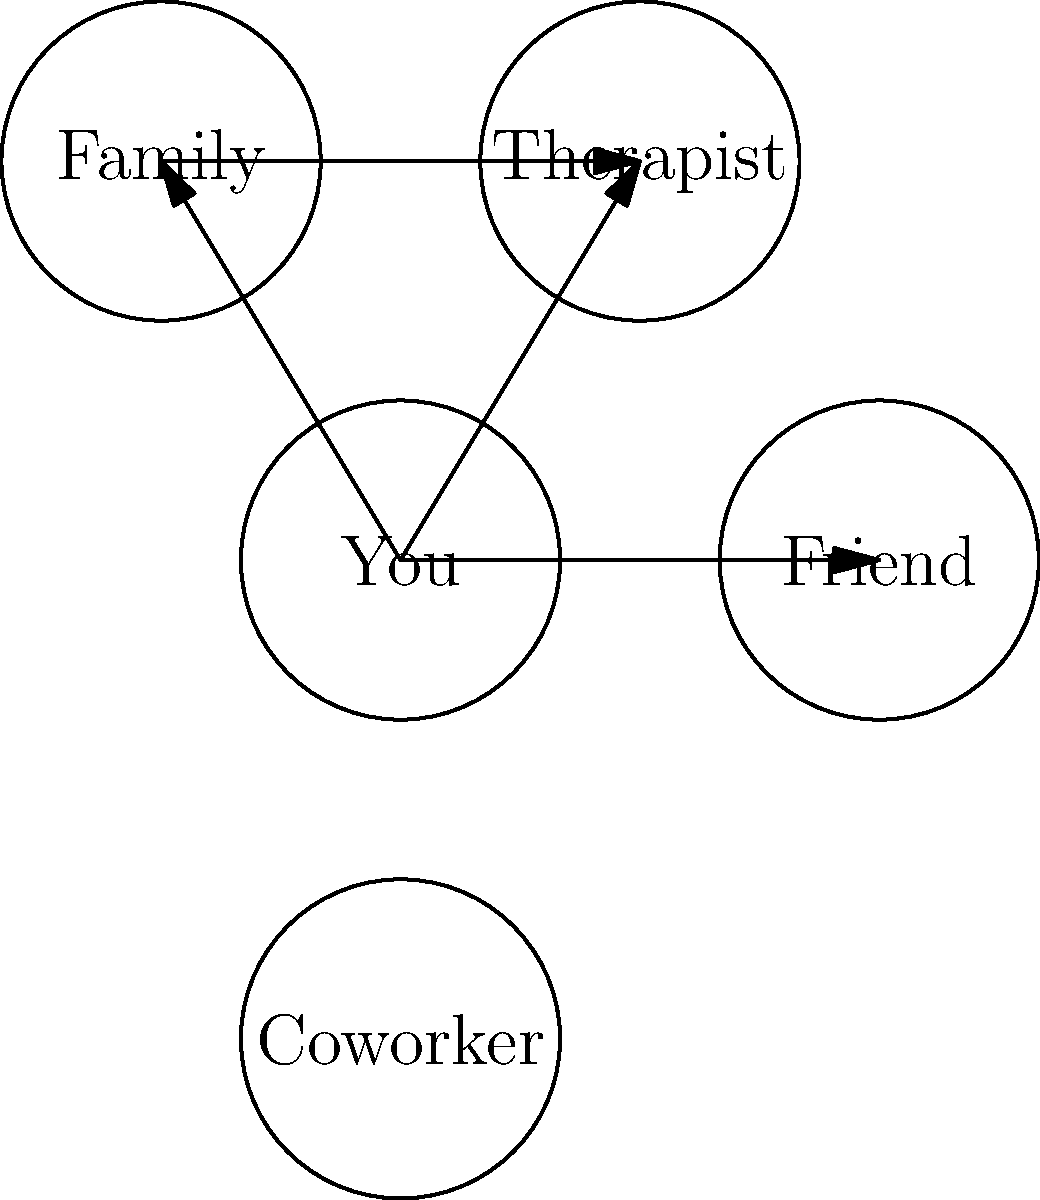In the social support network graph shown above, which node represents the strongest potential for developing a healthy support system, considering the challenges of interpersonal relationships due to early childhood trauma? To answer this question, we need to analyze the graph and consider the implications of each relationship in the context of early childhood trauma:

1. The graph shows five nodes: You, Friend, Family, Therapist, and Coworker.
2. Arrows indicate connections between nodes, representing established relationships.
3. For someone with early childhood trauma, developing healthy relationships can be challenging.
4. The "Therapist" node is crucial because:
   a) It's directly connected to "You," indicating an established therapeutic relationship.
   b) Therapists are trained to help individuals work through trauma and improve interpersonal skills.
   c) The therapeutic relationship can serve as a model for healthy interactions.
   d) It's also connected to "Family," suggesting potential for family therapy or guidance in family relationships.
5. The "Friend" node, while connected, may be more complex due to potential trust issues stemming from trauma.
6. The "Family" node, connected to both "You" and "Therapist," could be a source of support but may also be associated with the trauma.
7. The "Coworker" node is disconnected, indicating less potential for immediate support.

Given these factors, the "Therapist" node represents the strongest potential for developing a healthy support system, as it offers professional guidance, a safe space to work through trauma, and skills to improve other relationships.
Answer: Therapist 